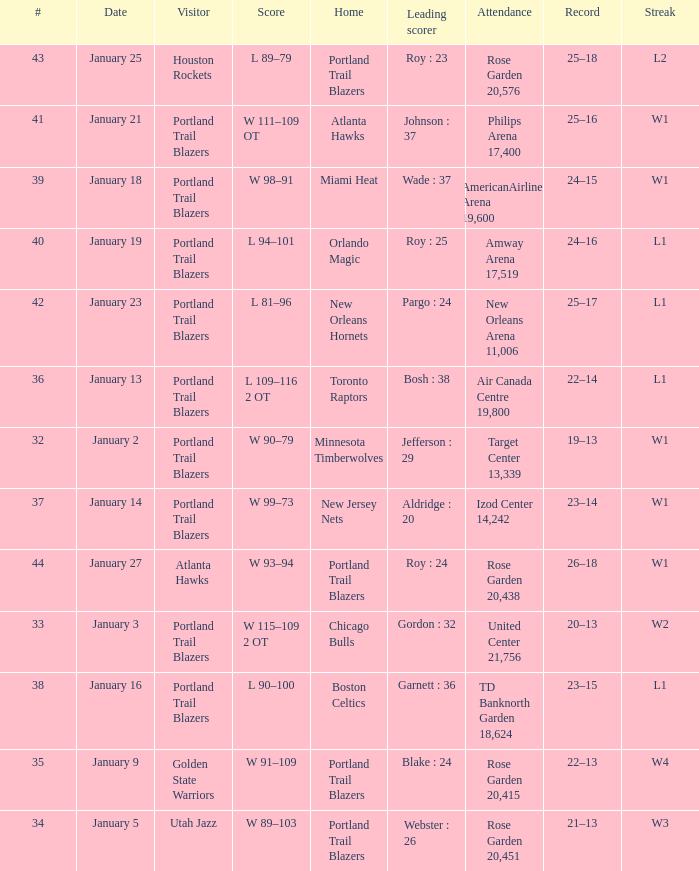Who are all the visitor with a record of 25–18 Houston Rockets. 